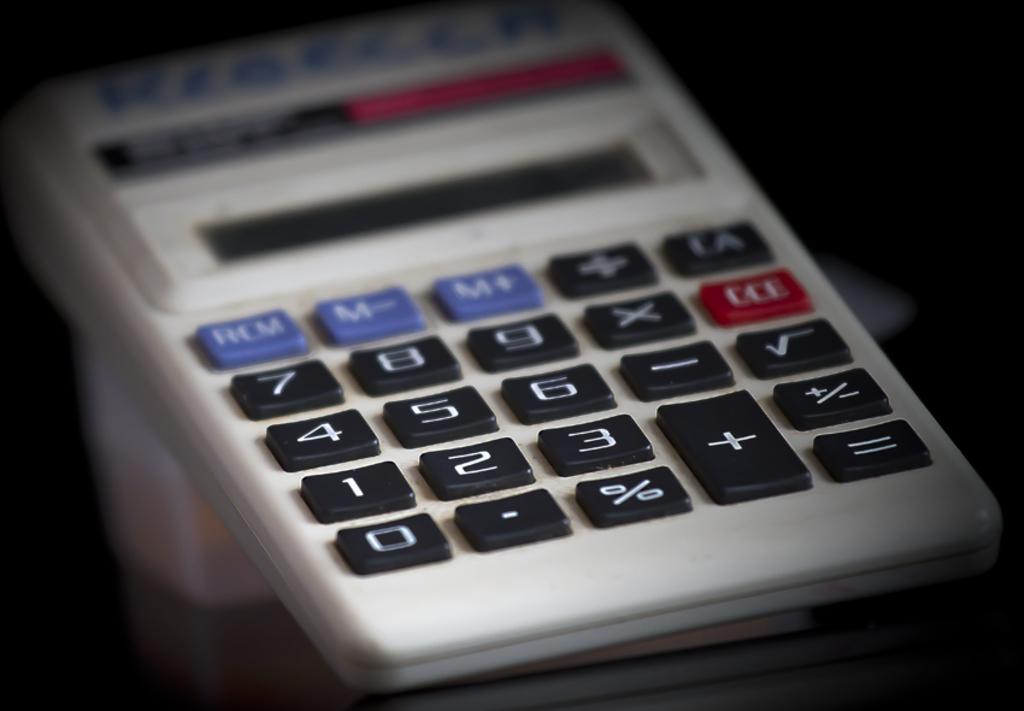<image>
Create a compact narrative representing the image presented. A calculator with the name Rebecca written across the top. 